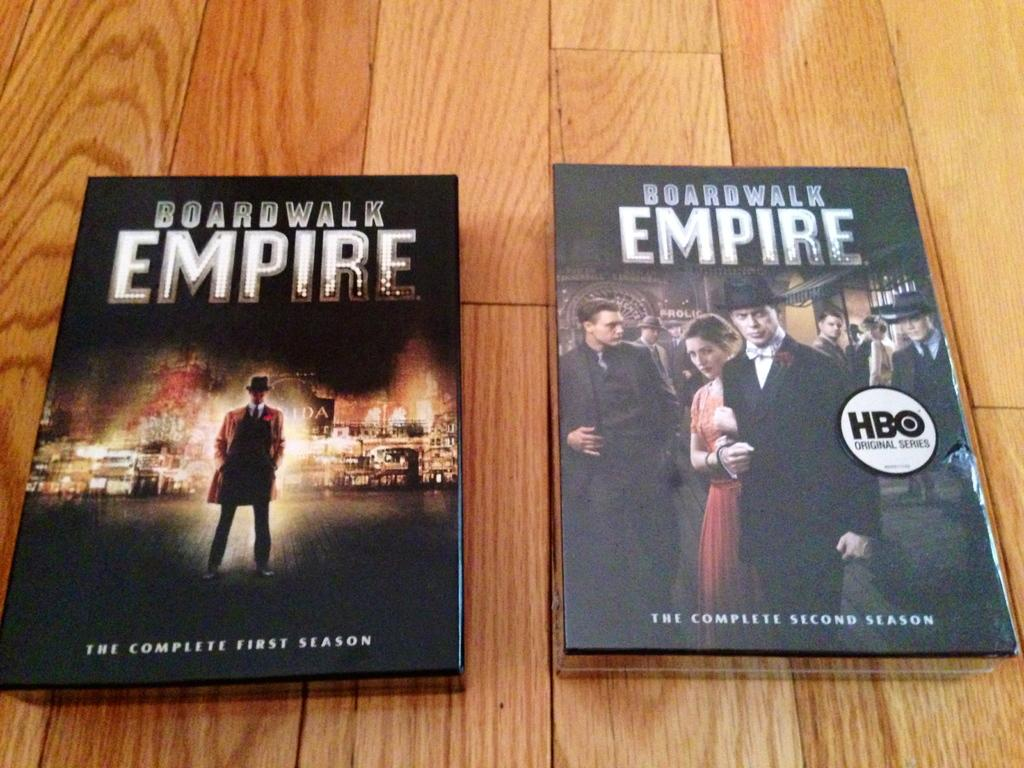<image>
Provide a brief description of the given image. The DVDs for the complete first and second seasons of the show Boardwalk Empire sit on a table next to each other. 